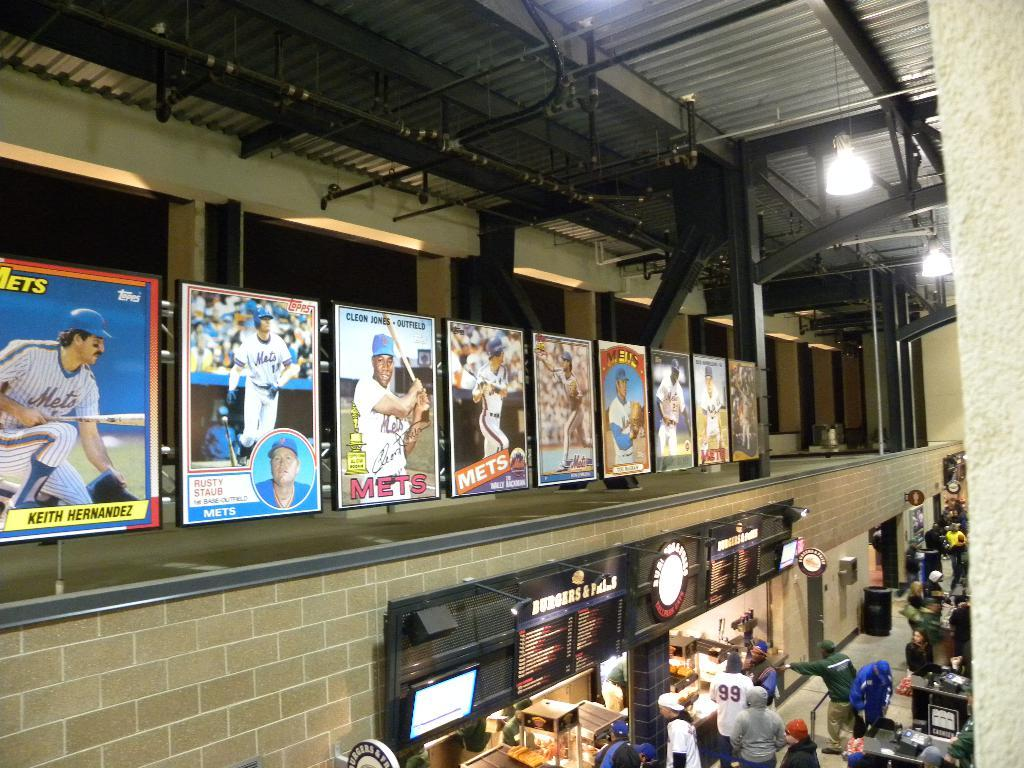<image>
Offer a succinct explanation of the picture presented. Bunch of people in a footcourt with one person wearing a number 99 jersey. 